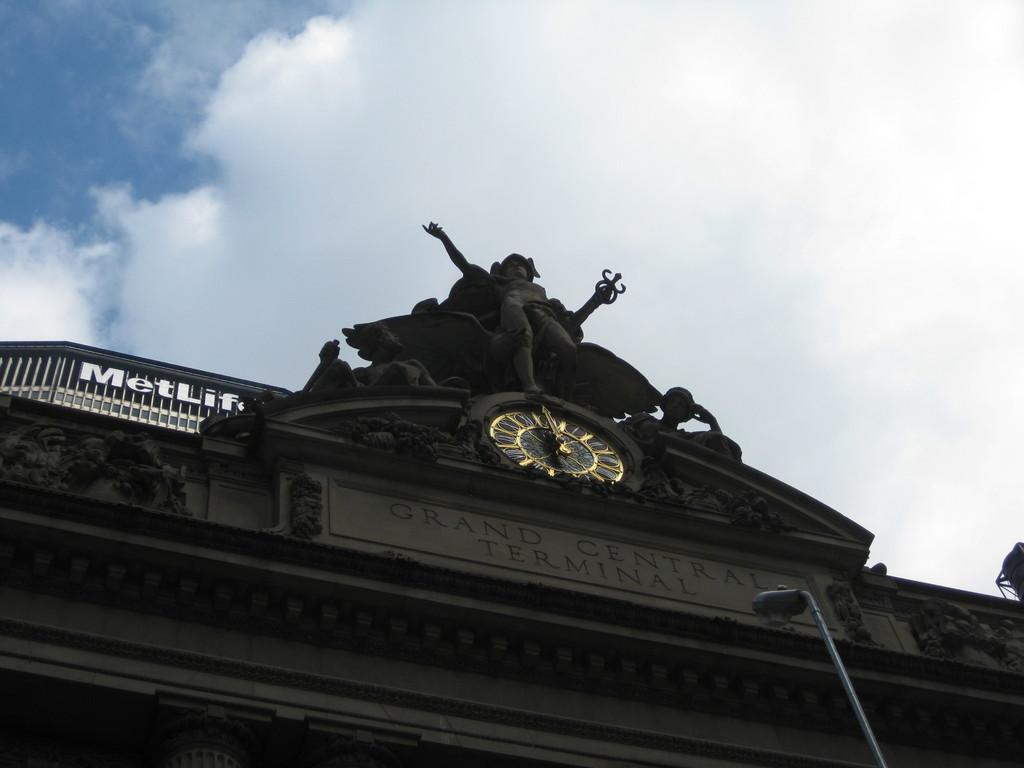<image>
Describe the image concisely. The facade of Grand Central Terminal features a clock with a statue above it. 